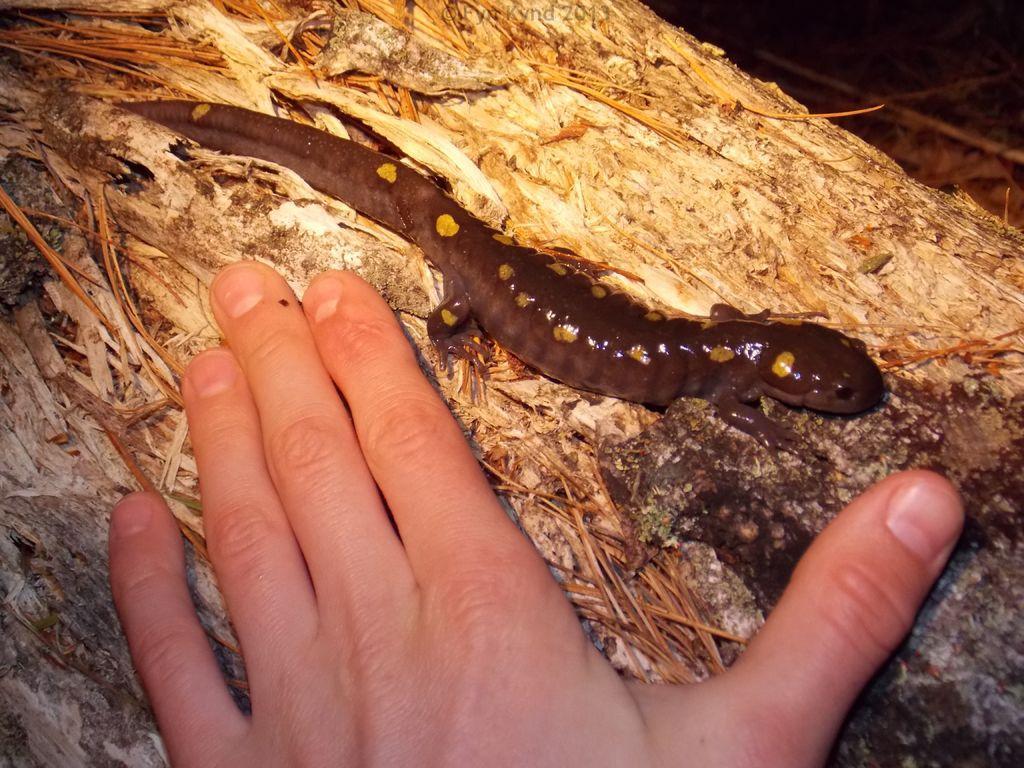Describe this image in one or two sentences. In this image there is a lizard on a surface, beside that there is a hand. 